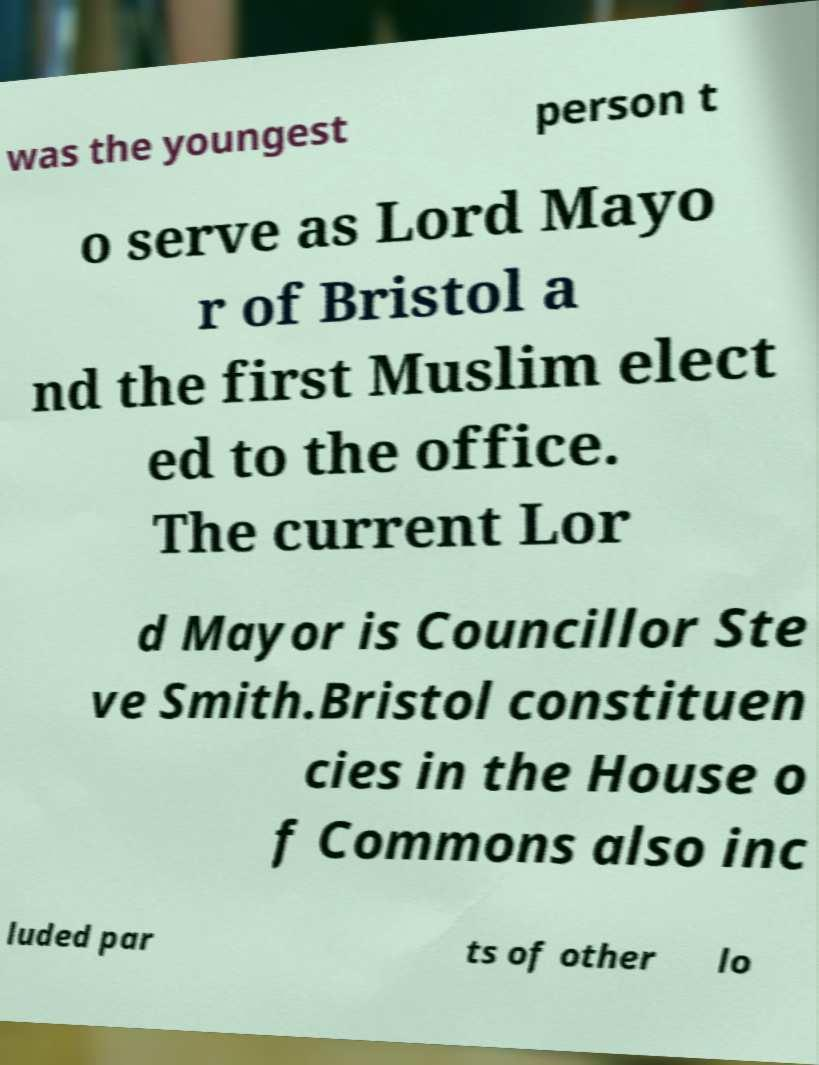Could you assist in decoding the text presented in this image and type it out clearly? was the youngest person t o serve as Lord Mayo r of Bristol a nd the first Muslim elect ed to the office. The current Lor d Mayor is Councillor Ste ve Smith.Bristol constituen cies in the House o f Commons also inc luded par ts of other lo 